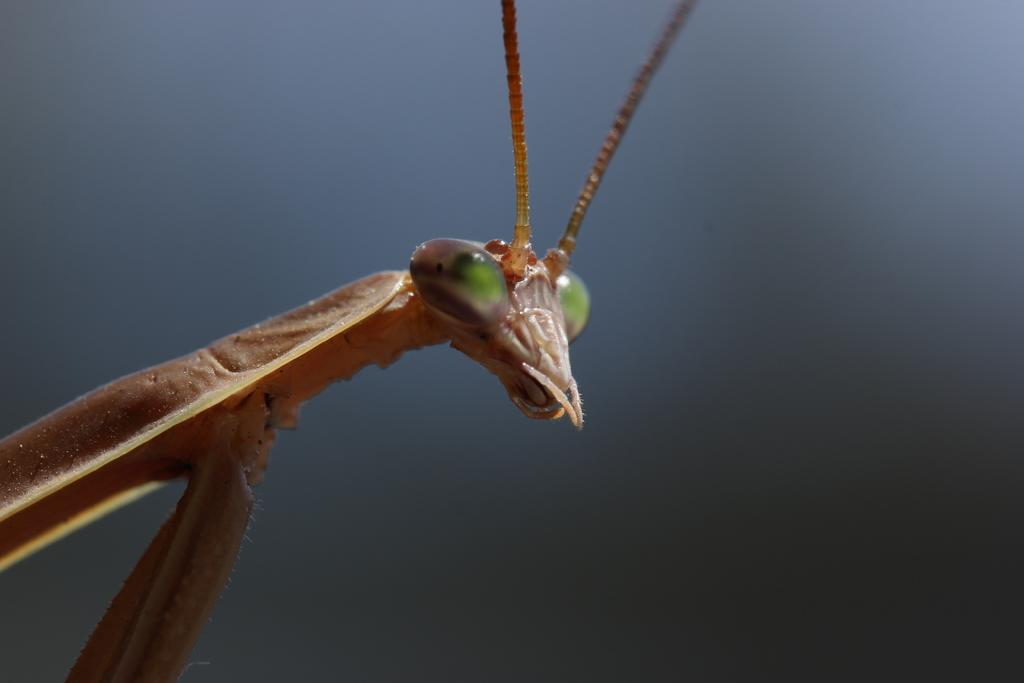What type of creature can be seen in the image? There is an insect in the image. What type of magic is being performed by the insect in the image? There is no magic being performed by the insect in the image, as it is a photograph of a real insect. 